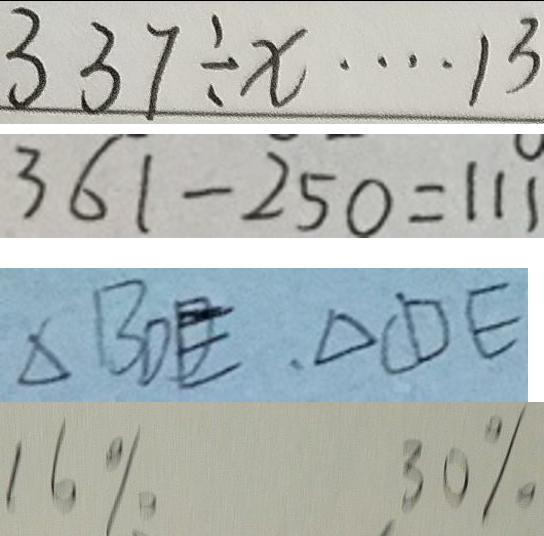Convert formula to latex. <formula><loc_0><loc_0><loc_500><loc_500>3 3 7 \div x \cdots 1 3 
 3 6 1 - 2 5 0 = 1 1 1 
 \Delta B D E , \Delta C D E 
 1 6 \% 3 0 \%</formula> 